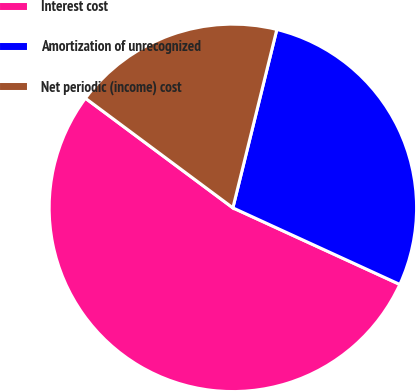<chart> <loc_0><loc_0><loc_500><loc_500><pie_chart><fcel>Interest cost<fcel>Amortization of unrecognized<fcel>Net periodic (income) cost<nl><fcel>53.33%<fcel>28.0%<fcel>18.67%<nl></chart> 